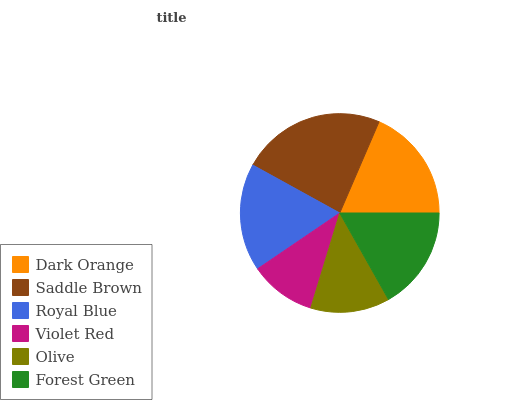Is Violet Red the minimum?
Answer yes or no. Yes. Is Saddle Brown the maximum?
Answer yes or no. Yes. Is Royal Blue the minimum?
Answer yes or no. No. Is Royal Blue the maximum?
Answer yes or no. No. Is Saddle Brown greater than Royal Blue?
Answer yes or no. Yes. Is Royal Blue less than Saddle Brown?
Answer yes or no. Yes. Is Royal Blue greater than Saddle Brown?
Answer yes or no. No. Is Saddle Brown less than Royal Blue?
Answer yes or no. No. Is Royal Blue the high median?
Answer yes or no. Yes. Is Forest Green the low median?
Answer yes or no. Yes. Is Forest Green the high median?
Answer yes or no. No. Is Violet Red the low median?
Answer yes or no. No. 